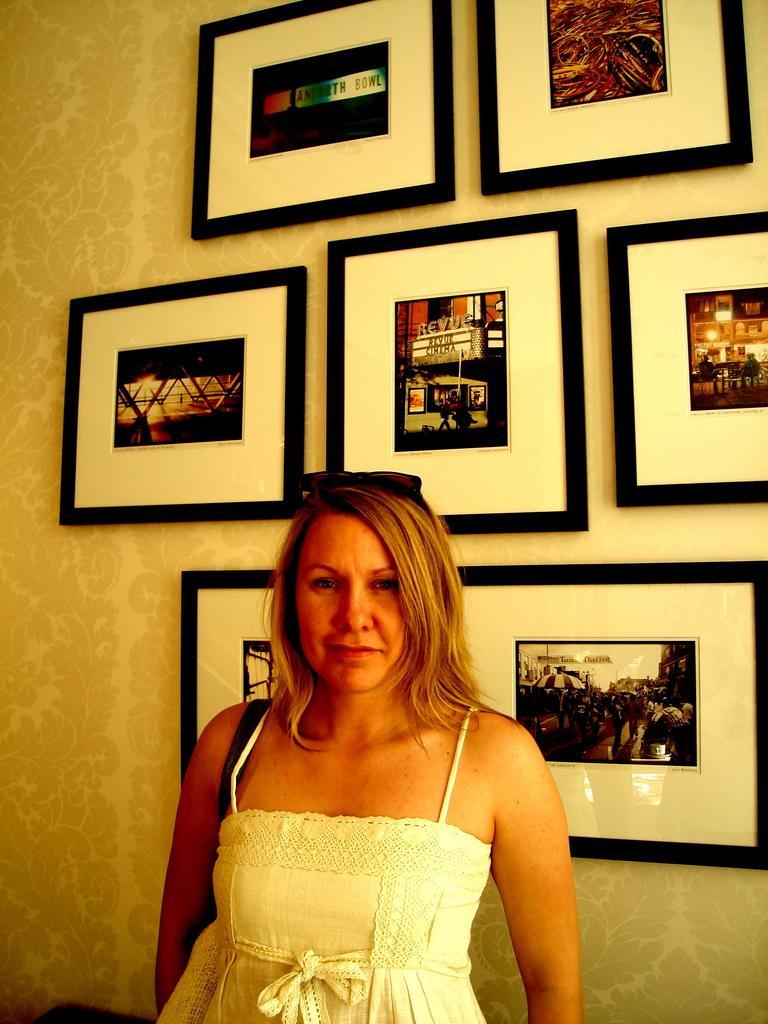Could you give a brief overview of what you see in this image? In this image I can see a woman is standing. The woman is wearing white color dress and smiling. In the background I can see photos on the wall. 